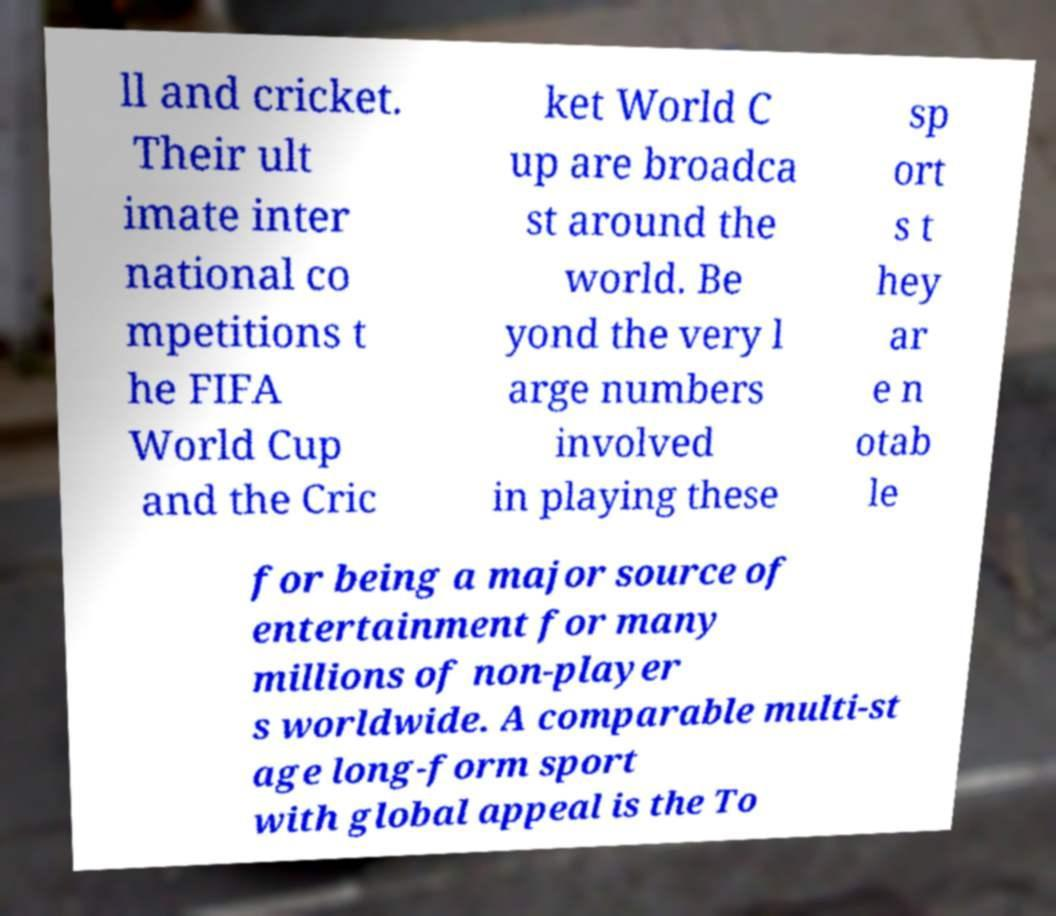Please read and relay the text visible in this image. What does it say? ll and cricket. Their ult imate inter national co mpetitions t he FIFA World Cup and the Cric ket World C up are broadca st around the world. Be yond the very l arge numbers involved in playing these sp ort s t hey ar e n otab le for being a major source of entertainment for many millions of non-player s worldwide. A comparable multi-st age long-form sport with global appeal is the To 